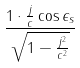Convert formula to latex. <formula><loc_0><loc_0><loc_500><loc_500>\frac { 1 \cdot \frac { j } { c } \cos \epsilon _ { s } } { \sqrt { 1 - \frac { j ^ { 2 } } { c ^ { 2 } } } }</formula> 